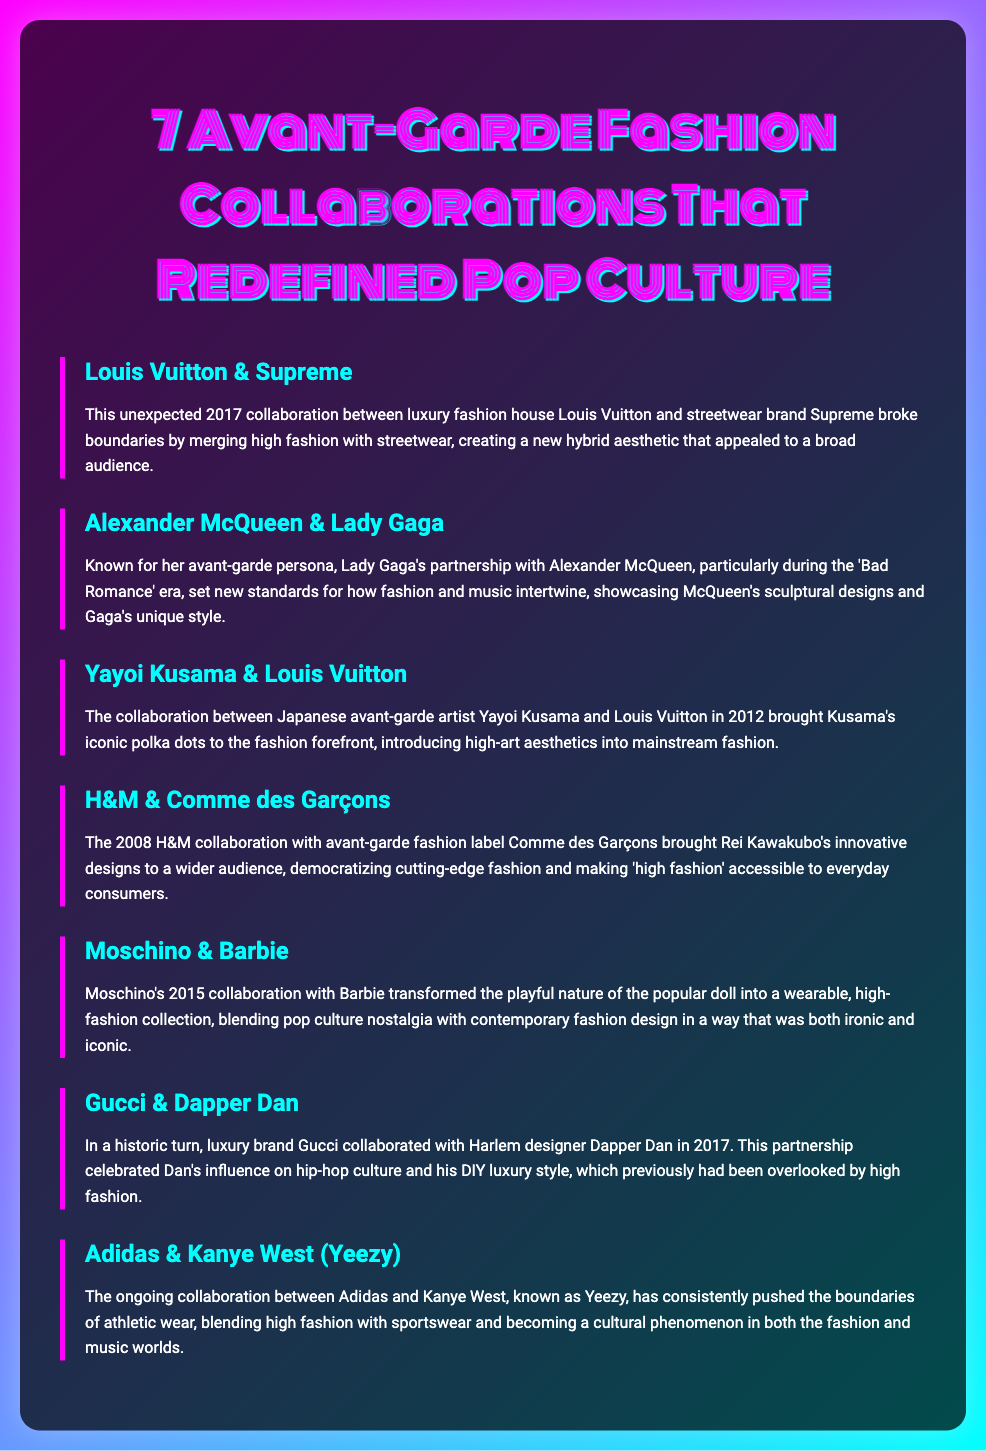What year did the Louis Vuitton and Supreme collaboration take place? The document states that the collaboration between Louis Vuitton and Supreme occurred in 2017.
Answer: 2017 Which avant-garde artist collaborated with Louis Vuitton in 2012? The document mentions that Yayoi Kusama collaborated with Louis Vuitton in 2012.
Answer: Yayoi Kusama What is the name of the designer who worked with H&M in 2008? The document specifies that Rei Kawakubo's label, Comme des Garçons, collaborated with H&M in 2008.
Answer: Comme des Garçons Which brand did Moschino collaborate with in 2015? According to the document, Moschino collaborated with Barbie in 2015.
Answer: Barbie What fashion concept did the Gucci and Dapper Dan collaboration celebrate? The collaboration celebrated Dapper Dan's influence on hip-hop culture and his DIY luxury style, as mentioned in the document.
Answer: Hip-hop culture What main themes do both the Yeezy and Adidas collaborations showcase? The document states that the Yeezy collaboration has blended high fashion with sportswear, showcasing innovation in athletic wear.
Answer: High fashion and sportswear How many collaborations are highlighted in the document? The document lists a total of seven collaborations that are discussed, as implied in the title.
Answer: Seven 